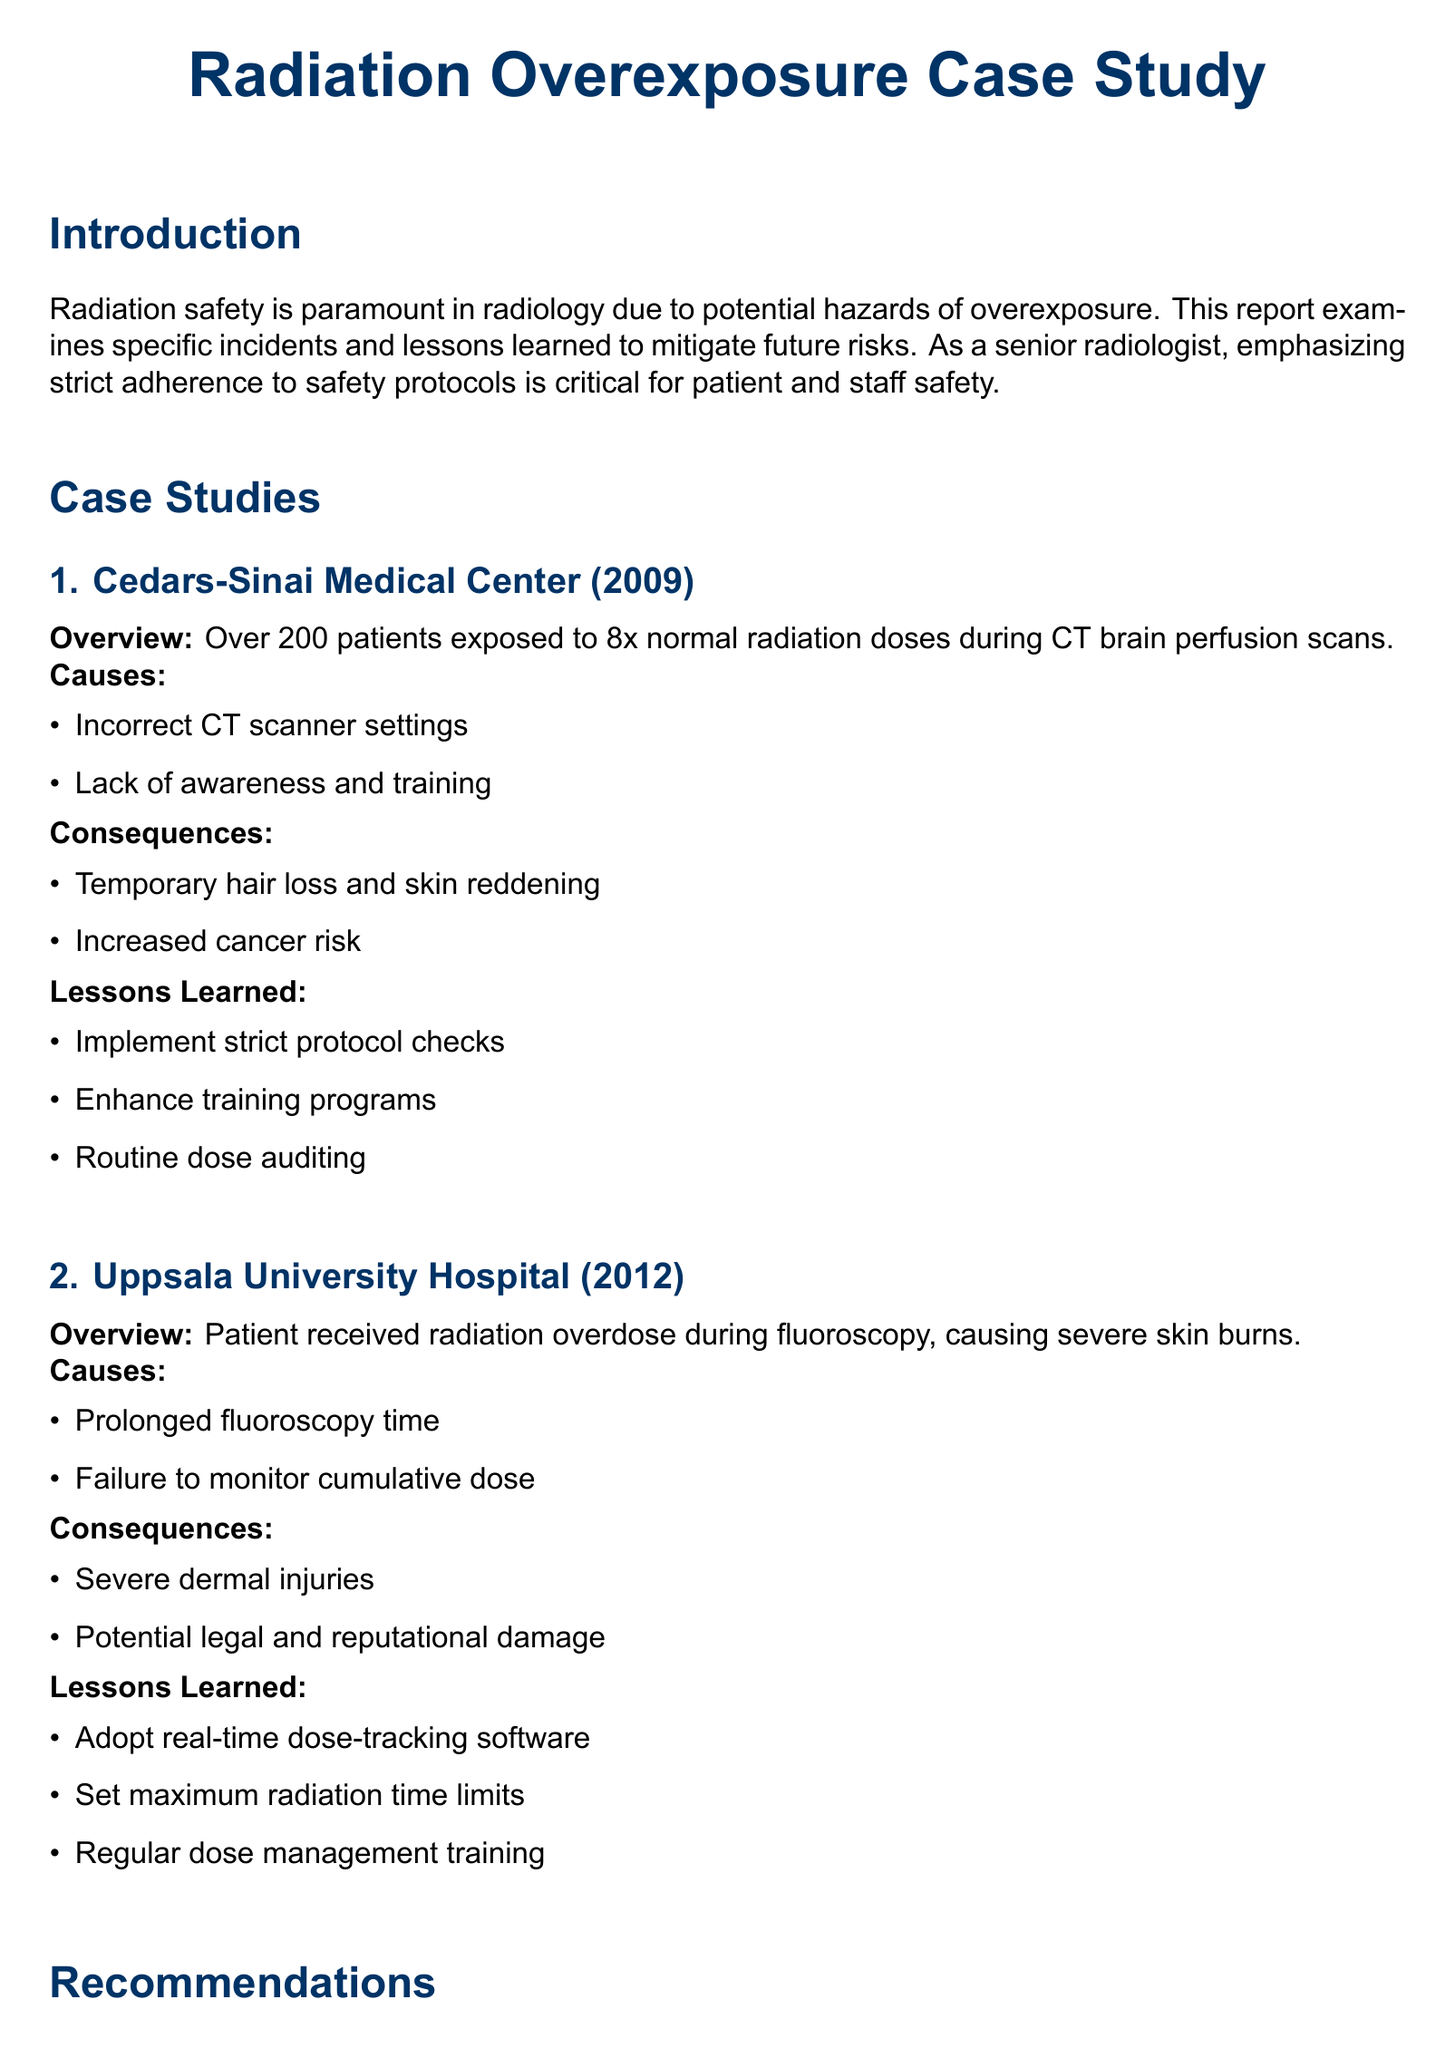What incident occurred at Cedars-Sinai Medical Center? The document states that over 200 patients were exposed to 8x normal radiation doses during CT brain perfusion scans.
Answer: CT brain perfusion scans What year did the Uppsala University Hospital incident take place? The document mentions that the incident took place in 2012.
Answer: 2012 What was a consequence of the radiation overexposure at Cedars-Sinai Medical Center? The document lists temporary hair loss and skin reddening as consequences.
Answer: Temporary hair loss and skin reddening What type of software is recommended for monitoring radiation doses? The document suggests adopting real-time dose-tracking software.
Answer: Real-time dose-tracking software What is one of the general measures recommended for radiation safety? The document recommends establishing comprehensive safety protocols.
Answer: Establish comprehensive safety protocols What were the causes of overexposure during fluoroscopy at Uppsala University Hospital? The document cites prolonged fluoroscopy time and failure to monitor cumulative dose.
Answer: Prolonged fluoroscopy time and failure to monitor cumulative dose How many case studies are detailed in the report? The document describes two case studies in the report.
Answer: Two What is an important aspect of the training recommendations? The document emphasizes the implementation of continuous education programs.
Answer: Continuous education programs 